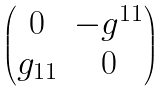<formula> <loc_0><loc_0><loc_500><loc_500>\begin{pmatrix} 0 & - g ^ { 1 1 } \\ g _ { 1 1 } & 0 \end{pmatrix}</formula> 